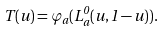<formula> <loc_0><loc_0><loc_500><loc_500>T ( u ) = \varphi _ { a } ( L _ { a } ^ { 0 } ( u , 1 - u ) ) .</formula> 